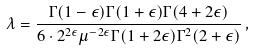Convert formula to latex. <formula><loc_0><loc_0><loc_500><loc_500>\lambda = \frac { \Gamma ( 1 - \epsilon ) \Gamma ( 1 + \epsilon ) \Gamma ( 4 + 2 \epsilon ) } { 6 \cdot 2 ^ { 2 \epsilon } \mu ^ { - 2 \epsilon } \Gamma ( 1 + 2 \epsilon ) \Gamma ^ { 2 } ( 2 + \epsilon ) } \, ,</formula> 